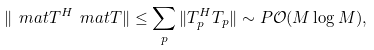<formula> <loc_0><loc_0><loc_500><loc_500>\| \ m a t T ^ { H } \ m a t T \| \leq \sum _ { p } \| T _ { p } ^ { H } T _ { p } \| \sim P \mathcal { O } ( M \log M ) ,</formula> 